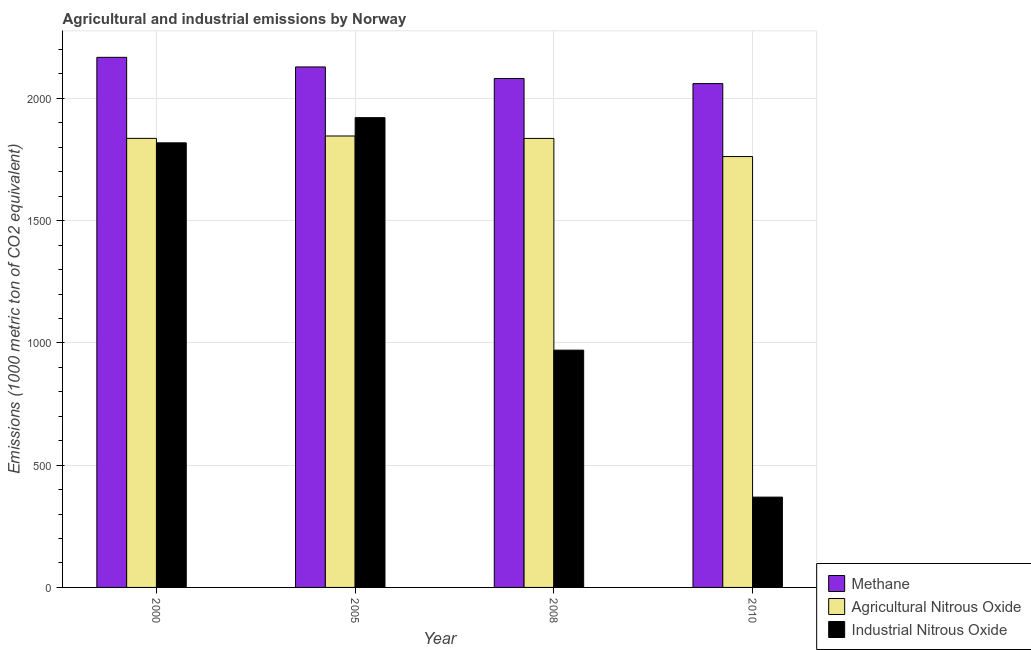How many different coloured bars are there?
Provide a short and direct response. 3. How many groups of bars are there?
Provide a short and direct response. 4. Are the number of bars on each tick of the X-axis equal?
Keep it short and to the point. Yes. How many bars are there on the 4th tick from the left?
Offer a very short reply. 3. What is the amount of agricultural nitrous oxide emissions in 2005?
Give a very brief answer. 1846.2. Across all years, what is the maximum amount of industrial nitrous oxide emissions?
Your response must be concise. 1921.2. Across all years, what is the minimum amount of industrial nitrous oxide emissions?
Offer a very short reply. 369.3. In which year was the amount of methane emissions maximum?
Give a very brief answer. 2000. What is the total amount of methane emissions in the graph?
Your answer should be very brief. 8438.3. What is the difference between the amount of agricultural nitrous oxide emissions in 2008 and that in 2010?
Your answer should be compact. 74.2. What is the difference between the amount of industrial nitrous oxide emissions in 2010 and the amount of methane emissions in 2005?
Provide a short and direct response. -1551.9. What is the average amount of agricultural nitrous oxide emissions per year?
Provide a short and direct response. 1820.28. In the year 2010, what is the difference between the amount of industrial nitrous oxide emissions and amount of agricultural nitrous oxide emissions?
Offer a terse response. 0. What is the ratio of the amount of agricultural nitrous oxide emissions in 2000 to that in 2008?
Offer a very short reply. 1. Is the difference between the amount of methane emissions in 2000 and 2008 greater than the difference between the amount of agricultural nitrous oxide emissions in 2000 and 2008?
Your answer should be compact. No. What is the difference between the highest and the second highest amount of methane emissions?
Provide a short and direct response. 39.3. What is the difference between the highest and the lowest amount of methane emissions?
Offer a terse response. 107.4. In how many years, is the amount of agricultural nitrous oxide emissions greater than the average amount of agricultural nitrous oxide emissions taken over all years?
Your answer should be compact. 3. What does the 1st bar from the left in 2005 represents?
Keep it short and to the point. Methane. What does the 1st bar from the right in 2000 represents?
Your answer should be compact. Industrial Nitrous Oxide. Is it the case that in every year, the sum of the amount of methane emissions and amount of agricultural nitrous oxide emissions is greater than the amount of industrial nitrous oxide emissions?
Offer a very short reply. Yes. Are all the bars in the graph horizontal?
Offer a terse response. No. Are the values on the major ticks of Y-axis written in scientific E-notation?
Ensure brevity in your answer.  No. Does the graph contain grids?
Give a very brief answer. Yes. How are the legend labels stacked?
Provide a short and direct response. Vertical. What is the title of the graph?
Your response must be concise. Agricultural and industrial emissions by Norway. Does "Coal" appear as one of the legend labels in the graph?
Your response must be concise. No. What is the label or title of the Y-axis?
Your answer should be very brief. Emissions (1000 metric ton of CO2 equivalent). What is the Emissions (1000 metric ton of CO2 equivalent) of Methane in 2000?
Offer a very short reply. 2167.9. What is the Emissions (1000 metric ton of CO2 equivalent) of Agricultural Nitrous Oxide in 2000?
Keep it short and to the point. 1836.5. What is the Emissions (1000 metric ton of CO2 equivalent) in Industrial Nitrous Oxide in 2000?
Your answer should be very brief. 1818.2. What is the Emissions (1000 metric ton of CO2 equivalent) in Methane in 2005?
Keep it short and to the point. 2128.6. What is the Emissions (1000 metric ton of CO2 equivalent) in Agricultural Nitrous Oxide in 2005?
Your response must be concise. 1846.2. What is the Emissions (1000 metric ton of CO2 equivalent) of Industrial Nitrous Oxide in 2005?
Give a very brief answer. 1921.2. What is the Emissions (1000 metric ton of CO2 equivalent) in Methane in 2008?
Your answer should be compact. 2081.3. What is the Emissions (1000 metric ton of CO2 equivalent) of Agricultural Nitrous Oxide in 2008?
Your response must be concise. 1836.3. What is the Emissions (1000 metric ton of CO2 equivalent) in Industrial Nitrous Oxide in 2008?
Offer a terse response. 970.4. What is the Emissions (1000 metric ton of CO2 equivalent) in Methane in 2010?
Your answer should be compact. 2060.5. What is the Emissions (1000 metric ton of CO2 equivalent) of Agricultural Nitrous Oxide in 2010?
Provide a succinct answer. 1762.1. What is the Emissions (1000 metric ton of CO2 equivalent) of Industrial Nitrous Oxide in 2010?
Provide a succinct answer. 369.3. Across all years, what is the maximum Emissions (1000 metric ton of CO2 equivalent) in Methane?
Your answer should be very brief. 2167.9. Across all years, what is the maximum Emissions (1000 metric ton of CO2 equivalent) of Agricultural Nitrous Oxide?
Offer a terse response. 1846.2. Across all years, what is the maximum Emissions (1000 metric ton of CO2 equivalent) of Industrial Nitrous Oxide?
Provide a succinct answer. 1921.2. Across all years, what is the minimum Emissions (1000 metric ton of CO2 equivalent) of Methane?
Give a very brief answer. 2060.5. Across all years, what is the minimum Emissions (1000 metric ton of CO2 equivalent) in Agricultural Nitrous Oxide?
Provide a short and direct response. 1762.1. Across all years, what is the minimum Emissions (1000 metric ton of CO2 equivalent) in Industrial Nitrous Oxide?
Ensure brevity in your answer.  369.3. What is the total Emissions (1000 metric ton of CO2 equivalent) in Methane in the graph?
Your answer should be compact. 8438.3. What is the total Emissions (1000 metric ton of CO2 equivalent) of Agricultural Nitrous Oxide in the graph?
Your response must be concise. 7281.1. What is the total Emissions (1000 metric ton of CO2 equivalent) in Industrial Nitrous Oxide in the graph?
Your answer should be very brief. 5079.1. What is the difference between the Emissions (1000 metric ton of CO2 equivalent) in Methane in 2000 and that in 2005?
Provide a short and direct response. 39.3. What is the difference between the Emissions (1000 metric ton of CO2 equivalent) in Agricultural Nitrous Oxide in 2000 and that in 2005?
Your response must be concise. -9.7. What is the difference between the Emissions (1000 metric ton of CO2 equivalent) in Industrial Nitrous Oxide in 2000 and that in 2005?
Your answer should be compact. -103. What is the difference between the Emissions (1000 metric ton of CO2 equivalent) in Methane in 2000 and that in 2008?
Keep it short and to the point. 86.6. What is the difference between the Emissions (1000 metric ton of CO2 equivalent) of Agricultural Nitrous Oxide in 2000 and that in 2008?
Provide a succinct answer. 0.2. What is the difference between the Emissions (1000 metric ton of CO2 equivalent) of Industrial Nitrous Oxide in 2000 and that in 2008?
Keep it short and to the point. 847.8. What is the difference between the Emissions (1000 metric ton of CO2 equivalent) in Methane in 2000 and that in 2010?
Offer a terse response. 107.4. What is the difference between the Emissions (1000 metric ton of CO2 equivalent) in Agricultural Nitrous Oxide in 2000 and that in 2010?
Offer a very short reply. 74.4. What is the difference between the Emissions (1000 metric ton of CO2 equivalent) in Industrial Nitrous Oxide in 2000 and that in 2010?
Offer a very short reply. 1448.9. What is the difference between the Emissions (1000 metric ton of CO2 equivalent) of Methane in 2005 and that in 2008?
Provide a short and direct response. 47.3. What is the difference between the Emissions (1000 metric ton of CO2 equivalent) in Agricultural Nitrous Oxide in 2005 and that in 2008?
Keep it short and to the point. 9.9. What is the difference between the Emissions (1000 metric ton of CO2 equivalent) of Industrial Nitrous Oxide in 2005 and that in 2008?
Keep it short and to the point. 950.8. What is the difference between the Emissions (1000 metric ton of CO2 equivalent) of Methane in 2005 and that in 2010?
Provide a succinct answer. 68.1. What is the difference between the Emissions (1000 metric ton of CO2 equivalent) of Agricultural Nitrous Oxide in 2005 and that in 2010?
Your response must be concise. 84.1. What is the difference between the Emissions (1000 metric ton of CO2 equivalent) of Industrial Nitrous Oxide in 2005 and that in 2010?
Your response must be concise. 1551.9. What is the difference between the Emissions (1000 metric ton of CO2 equivalent) in Methane in 2008 and that in 2010?
Provide a short and direct response. 20.8. What is the difference between the Emissions (1000 metric ton of CO2 equivalent) in Agricultural Nitrous Oxide in 2008 and that in 2010?
Give a very brief answer. 74.2. What is the difference between the Emissions (1000 metric ton of CO2 equivalent) in Industrial Nitrous Oxide in 2008 and that in 2010?
Your answer should be compact. 601.1. What is the difference between the Emissions (1000 metric ton of CO2 equivalent) of Methane in 2000 and the Emissions (1000 metric ton of CO2 equivalent) of Agricultural Nitrous Oxide in 2005?
Offer a very short reply. 321.7. What is the difference between the Emissions (1000 metric ton of CO2 equivalent) in Methane in 2000 and the Emissions (1000 metric ton of CO2 equivalent) in Industrial Nitrous Oxide in 2005?
Make the answer very short. 246.7. What is the difference between the Emissions (1000 metric ton of CO2 equivalent) of Agricultural Nitrous Oxide in 2000 and the Emissions (1000 metric ton of CO2 equivalent) of Industrial Nitrous Oxide in 2005?
Provide a succinct answer. -84.7. What is the difference between the Emissions (1000 metric ton of CO2 equivalent) in Methane in 2000 and the Emissions (1000 metric ton of CO2 equivalent) in Agricultural Nitrous Oxide in 2008?
Offer a terse response. 331.6. What is the difference between the Emissions (1000 metric ton of CO2 equivalent) of Methane in 2000 and the Emissions (1000 metric ton of CO2 equivalent) of Industrial Nitrous Oxide in 2008?
Keep it short and to the point. 1197.5. What is the difference between the Emissions (1000 metric ton of CO2 equivalent) in Agricultural Nitrous Oxide in 2000 and the Emissions (1000 metric ton of CO2 equivalent) in Industrial Nitrous Oxide in 2008?
Your answer should be compact. 866.1. What is the difference between the Emissions (1000 metric ton of CO2 equivalent) of Methane in 2000 and the Emissions (1000 metric ton of CO2 equivalent) of Agricultural Nitrous Oxide in 2010?
Give a very brief answer. 405.8. What is the difference between the Emissions (1000 metric ton of CO2 equivalent) of Methane in 2000 and the Emissions (1000 metric ton of CO2 equivalent) of Industrial Nitrous Oxide in 2010?
Your answer should be compact. 1798.6. What is the difference between the Emissions (1000 metric ton of CO2 equivalent) of Agricultural Nitrous Oxide in 2000 and the Emissions (1000 metric ton of CO2 equivalent) of Industrial Nitrous Oxide in 2010?
Your answer should be very brief. 1467.2. What is the difference between the Emissions (1000 metric ton of CO2 equivalent) in Methane in 2005 and the Emissions (1000 metric ton of CO2 equivalent) in Agricultural Nitrous Oxide in 2008?
Your answer should be very brief. 292.3. What is the difference between the Emissions (1000 metric ton of CO2 equivalent) of Methane in 2005 and the Emissions (1000 metric ton of CO2 equivalent) of Industrial Nitrous Oxide in 2008?
Make the answer very short. 1158.2. What is the difference between the Emissions (1000 metric ton of CO2 equivalent) of Agricultural Nitrous Oxide in 2005 and the Emissions (1000 metric ton of CO2 equivalent) of Industrial Nitrous Oxide in 2008?
Provide a succinct answer. 875.8. What is the difference between the Emissions (1000 metric ton of CO2 equivalent) of Methane in 2005 and the Emissions (1000 metric ton of CO2 equivalent) of Agricultural Nitrous Oxide in 2010?
Your response must be concise. 366.5. What is the difference between the Emissions (1000 metric ton of CO2 equivalent) in Methane in 2005 and the Emissions (1000 metric ton of CO2 equivalent) in Industrial Nitrous Oxide in 2010?
Offer a terse response. 1759.3. What is the difference between the Emissions (1000 metric ton of CO2 equivalent) of Agricultural Nitrous Oxide in 2005 and the Emissions (1000 metric ton of CO2 equivalent) of Industrial Nitrous Oxide in 2010?
Offer a terse response. 1476.9. What is the difference between the Emissions (1000 metric ton of CO2 equivalent) in Methane in 2008 and the Emissions (1000 metric ton of CO2 equivalent) in Agricultural Nitrous Oxide in 2010?
Your answer should be compact. 319.2. What is the difference between the Emissions (1000 metric ton of CO2 equivalent) of Methane in 2008 and the Emissions (1000 metric ton of CO2 equivalent) of Industrial Nitrous Oxide in 2010?
Provide a short and direct response. 1712. What is the difference between the Emissions (1000 metric ton of CO2 equivalent) in Agricultural Nitrous Oxide in 2008 and the Emissions (1000 metric ton of CO2 equivalent) in Industrial Nitrous Oxide in 2010?
Offer a terse response. 1467. What is the average Emissions (1000 metric ton of CO2 equivalent) of Methane per year?
Your answer should be very brief. 2109.57. What is the average Emissions (1000 metric ton of CO2 equivalent) in Agricultural Nitrous Oxide per year?
Provide a succinct answer. 1820.28. What is the average Emissions (1000 metric ton of CO2 equivalent) in Industrial Nitrous Oxide per year?
Ensure brevity in your answer.  1269.78. In the year 2000, what is the difference between the Emissions (1000 metric ton of CO2 equivalent) in Methane and Emissions (1000 metric ton of CO2 equivalent) in Agricultural Nitrous Oxide?
Offer a very short reply. 331.4. In the year 2000, what is the difference between the Emissions (1000 metric ton of CO2 equivalent) of Methane and Emissions (1000 metric ton of CO2 equivalent) of Industrial Nitrous Oxide?
Make the answer very short. 349.7. In the year 2005, what is the difference between the Emissions (1000 metric ton of CO2 equivalent) in Methane and Emissions (1000 metric ton of CO2 equivalent) in Agricultural Nitrous Oxide?
Keep it short and to the point. 282.4. In the year 2005, what is the difference between the Emissions (1000 metric ton of CO2 equivalent) of Methane and Emissions (1000 metric ton of CO2 equivalent) of Industrial Nitrous Oxide?
Your answer should be compact. 207.4. In the year 2005, what is the difference between the Emissions (1000 metric ton of CO2 equivalent) of Agricultural Nitrous Oxide and Emissions (1000 metric ton of CO2 equivalent) of Industrial Nitrous Oxide?
Your answer should be compact. -75. In the year 2008, what is the difference between the Emissions (1000 metric ton of CO2 equivalent) of Methane and Emissions (1000 metric ton of CO2 equivalent) of Agricultural Nitrous Oxide?
Your answer should be very brief. 245. In the year 2008, what is the difference between the Emissions (1000 metric ton of CO2 equivalent) in Methane and Emissions (1000 metric ton of CO2 equivalent) in Industrial Nitrous Oxide?
Your answer should be very brief. 1110.9. In the year 2008, what is the difference between the Emissions (1000 metric ton of CO2 equivalent) of Agricultural Nitrous Oxide and Emissions (1000 metric ton of CO2 equivalent) of Industrial Nitrous Oxide?
Your response must be concise. 865.9. In the year 2010, what is the difference between the Emissions (1000 metric ton of CO2 equivalent) of Methane and Emissions (1000 metric ton of CO2 equivalent) of Agricultural Nitrous Oxide?
Your answer should be very brief. 298.4. In the year 2010, what is the difference between the Emissions (1000 metric ton of CO2 equivalent) of Methane and Emissions (1000 metric ton of CO2 equivalent) of Industrial Nitrous Oxide?
Offer a very short reply. 1691.2. In the year 2010, what is the difference between the Emissions (1000 metric ton of CO2 equivalent) of Agricultural Nitrous Oxide and Emissions (1000 metric ton of CO2 equivalent) of Industrial Nitrous Oxide?
Offer a very short reply. 1392.8. What is the ratio of the Emissions (1000 metric ton of CO2 equivalent) of Methane in 2000 to that in 2005?
Give a very brief answer. 1.02. What is the ratio of the Emissions (1000 metric ton of CO2 equivalent) of Industrial Nitrous Oxide in 2000 to that in 2005?
Offer a very short reply. 0.95. What is the ratio of the Emissions (1000 metric ton of CO2 equivalent) of Methane in 2000 to that in 2008?
Provide a succinct answer. 1.04. What is the ratio of the Emissions (1000 metric ton of CO2 equivalent) in Agricultural Nitrous Oxide in 2000 to that in 2008?
Make the answer very short. 1. What is the ratio of the Emissions (1000 metric ton of CO2 equivalent) in Industrial Nitrous Oxide in 2000 to that in 2008?
Ensure brevity in your answer.  1.87. What is the ratio of the Emissions (1000 metric ton of CO2 equivalent) in Methane in 2000 to that in 2010?
Your answer should be very brief. 1.05. What is the ratio of the Emissions (1000 metric ton of CO2 equivalent) in Agricultural Nitrous Oxide in 2000 to that in 2010?
Ensure brevity in your answer.  1.04. What is the ratio of the Emissions (1000 metric ton of CO2 equivalent) of Industrial Nitrous Oxide in 2000 to that in 2010?
Your answer should be very brief. 4.92. What is the ratio of the Emissions (1000 metric ton of CO2 equivalent) in Methane in 2005 to that in 2008?
Your answer should be very brief. 1.02. What is the ratio of the Emissions (1000 metric ton of CO2 equivalent) of Agricultural Nitrous Oxide in 2005 to that in 2008?
Provide a succinct answer. 1.01. What is the ratio of the Emissions (1000 metric ton of CO2 equivalent) of Industrial Nitrous Oxide in 2005 to that in 2008?
Provide a short and direct response. 1.98. What is the ratio of the Emissions (1000 metric ton of CO2 equivalent) of Methane in 2005 to that in 2010?
Give a very brief answer. 1.03. What is the ratio of the Emissions (1000 metric ton of CO2 equivalent) in Agricultural Nitrous Oxide in 2005 to that in 2010?
Ensure brevity in your answer.  1.05. What is the ratio of the Emissions (1000 metric ton of CO2 equivalent) of Industrial Nitrous Oxide in 2005 to that in 2010?
Offer a very short reply. 5.2. What is the ratio of the Emissions (1000 metric ton of CO2 equivalent) in Agricultural Nitrous Oxide in 2008 to that in 2010?
Make the answer very short. 1.04. What is the ratio of the Emissions (1000 metric ton of CO2 equivalent) in Industrial Nitrous Oxide in 2008 to that in 2010?
Your answer should be very brief. 2.63. What is the difference between the highest and the second highest Emissions (1000 metric ton of CO2 equivalent) in Methane?
Offer a terse response. 39.3. What is the difference between the highest and the second highest Emissions (1000 metric ton of CO2 equivalent) of Industrial Nitrous Oxide?
Ensure brevity in your answer.  103. What is the difference between the highest and the lowest Emissions (1000 metric ton of CO2 equivalent) of Methane?
Your answer should be compact. 107.4. What is the difference between the highest and the lowest Emissions (1000 metric ton of CO2 equivalent) in Agricultural Nitrous Oxide?
Provide a short and direct response. 84.1. What is the difference between the highest and the lowest Emissions (1000 metric ton of CO2 equivalent) of Industrial Nitrous Oxide?
Give a very brief answer. 1551.9. 